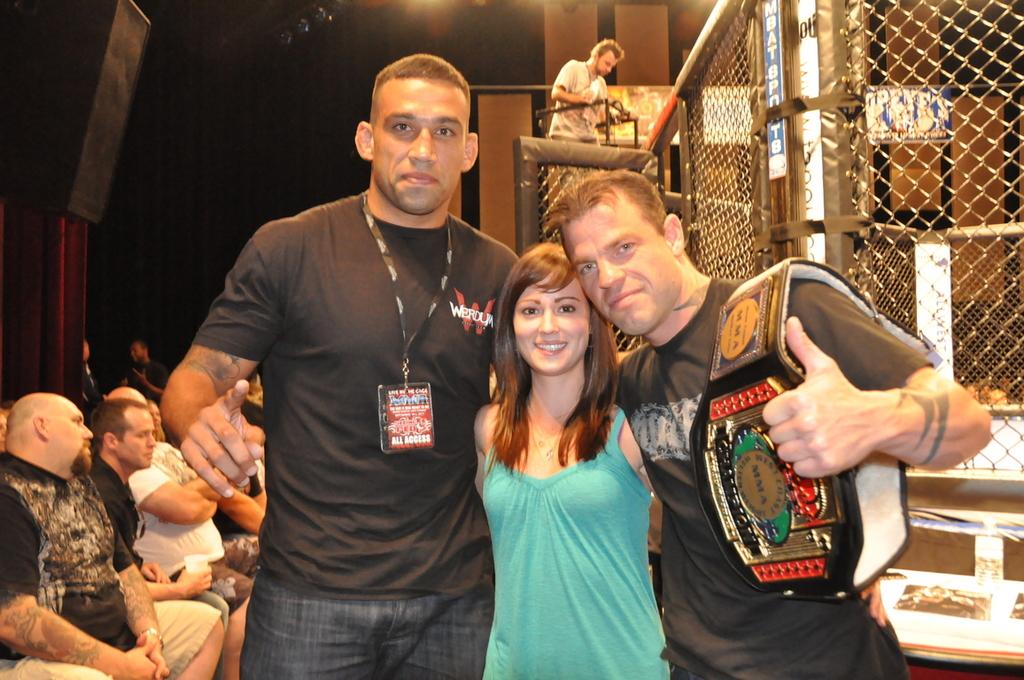What are the people in the center of the image doing? The three people standing and smiling in the center of the image are posing for the photo. What are the people on the left side of the image doing? The people sitting on the left side of the image are also posing for the photo. What can be seen in the background of the image? There is a mesh, a man, a wall, and lights visible in the background of the image. What type of heat can be felt coming from the jar in the image? There is no jar present in the image, so it is not possible to determine what type of heat might be felt. 